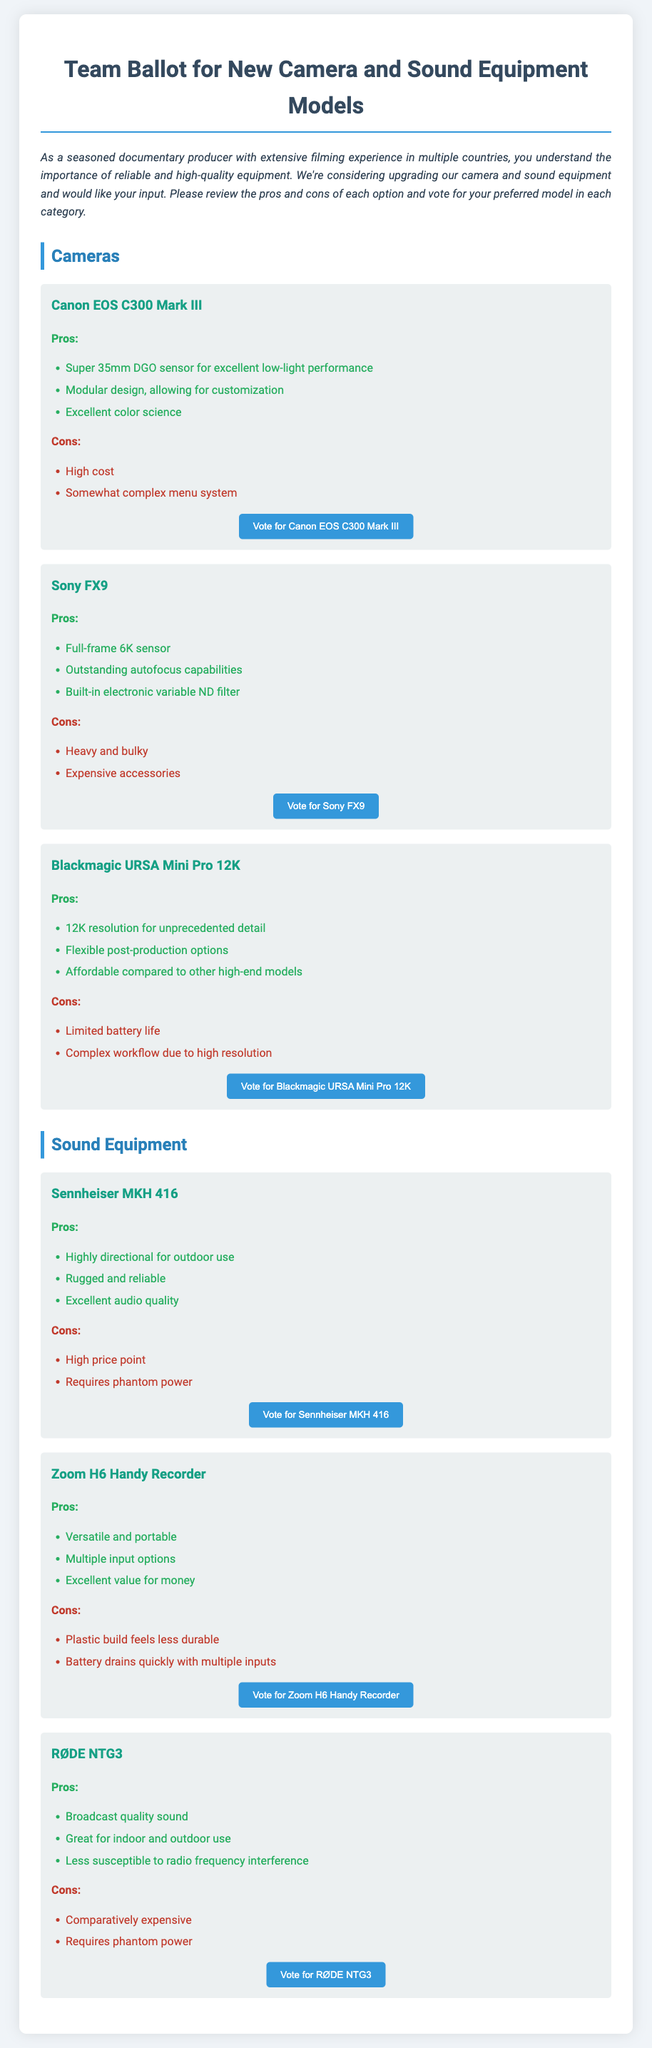What is the model of the first camera listed? The first camera listed in the document is the Canon EOS C300 Mark III.
Answer: Canon EOS C300 Mark III What is the primary advantage of the Sony FX9? The primary advantage of the Sony FX9 is that it has outstanding autofocus capabilities.
Answer: Outstanding autofocus capabilities How many models of sound equipment are presented? There are three models of sound equipment presented in the document.
Answer: Three What is a key disadvantage of the Blackmagic URSA Mini Pro 12K? A key disadvantage of the Blackmagic URSA Mini Pro 12K is its limited battery life.
Answer: Limited battery life Which microphone is known for broadcast quality sound? The microphone known for broadcast quality sound is the RØDE NTG3.
Answer: RØDE NTG3 What feature does the Sennheiser MKH 416 possess? The Sennheiser MKH 416 is highly directional for outdoor use.
Answer: Highly directional for outdoor use What is the resolution capability of the Blackmagic URSA Mini Pro 12K? The resolution capability of the Blackmagic URSA Mini Pro 12K is 12K.
Answer: 12K What is the price point of the Sennheiser MKH 416 categorized as? The price point of the Sennheiser MKH 416 is categorized as high.
Answer: High What is the main disadvantage of the Zoom H6 Handy Recorder? The main disadvantage of the Zoom H6 Handy Recorder is that the plastic build feels less durable.
Answer: Plastic build feels less durable 